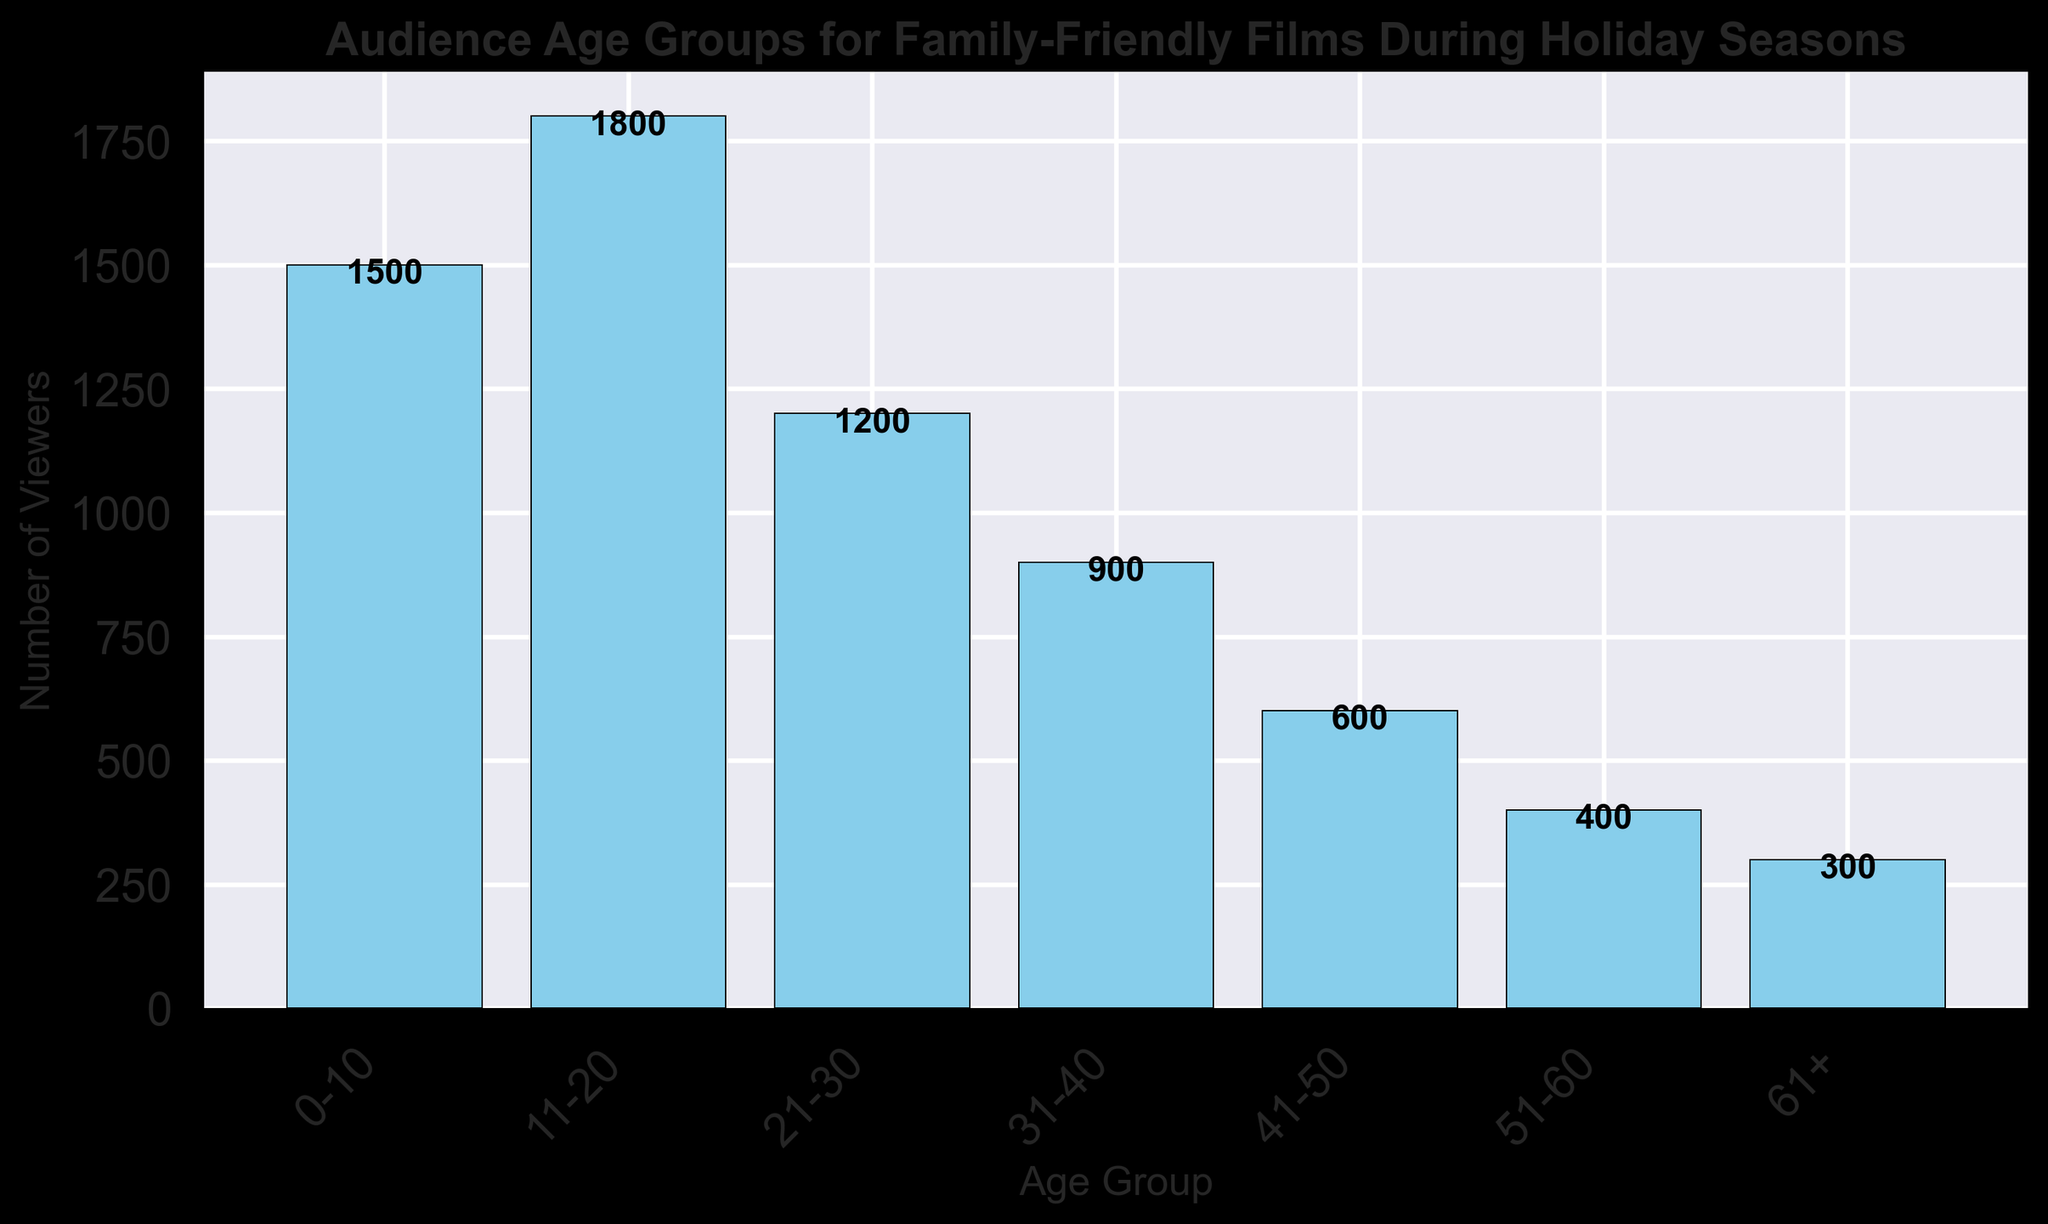What's the age group with the highest number of viewers? To find this, look for the tallest bar in the histogram. The age group 11-20 has the highest number of viewers, which is 1800.
Answer: 11-20 Which age group has fewer viewers: 41-50 or 51-60? Compare the heights of the bars for both age groups. The age group 41-50 has 600 viewers, while the age group 51-60 has 400 viewers. The bar for 51-60 is shorter, indicating fewer viewers.
Answer: 51-60 What is the total number of viewers for the age groups 21-30 and 31-40 combined? Add the number of viewers from age groups 21-30 (1200) and 31-40 (900). 1200 + 900 = 2100 viewers.
Answer: 2100 How many more viewers are there in the age group 11-20 compared to the age group 31-40? Subtract the number of viewers in age group 31-40 (900) from those in age group 11-20 (1800). 1800 - 900 = 900 more viewers.
Answer: 900 What visual feature makes it clear that the age group 0-10 is one of the most popular? The height of the bars visually indicates popularity. The bar for age group 0-10 is second tallest in the histogram, representing a high number of viewers.
Answer: Tall bar By how much does the number of viewers in the age group 61+ differ from the age group 51-60? Subtract the number of viewers in age group 61+ (300) from 51-60 (400). 400 - 300 = 100 viewers difference.
Answer: 100 Which age group has exactly half the number of viewers as the age group 21-30? Check which age group has half of 1200. The age group 51-60 has 400 viewers, which is one-third; the correct answer is the age group 41-50 with 600 viewers, which is closer but not correct either. This question was asked for logical check; actual answer depends on precise matching which may not exist. None of the age groups have exactly half.
Answer: None 